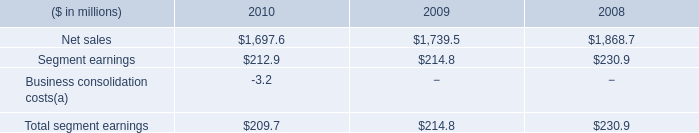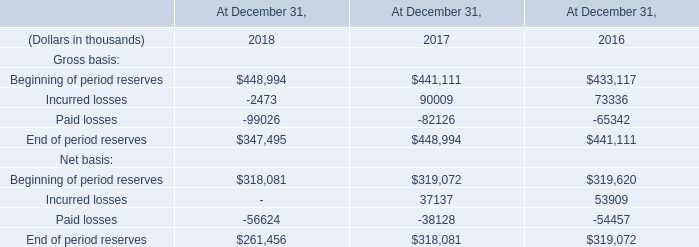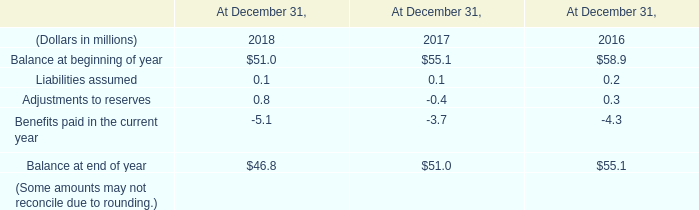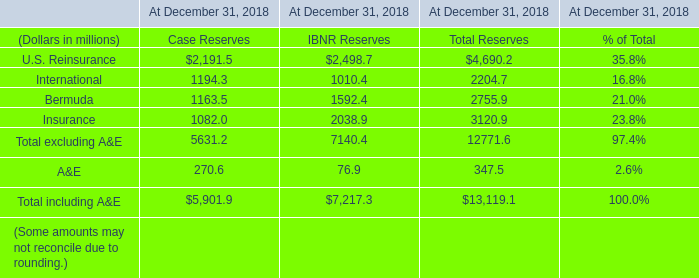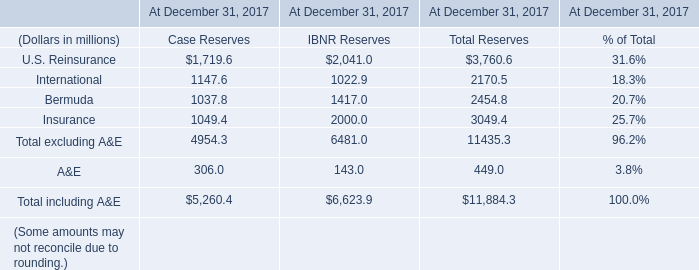the segment sales decrease in 2010 was what percent of the decrease in 2009? 
Computations: ((129.2 - 41.9) / 129.2)
Answer: 0.6757. 